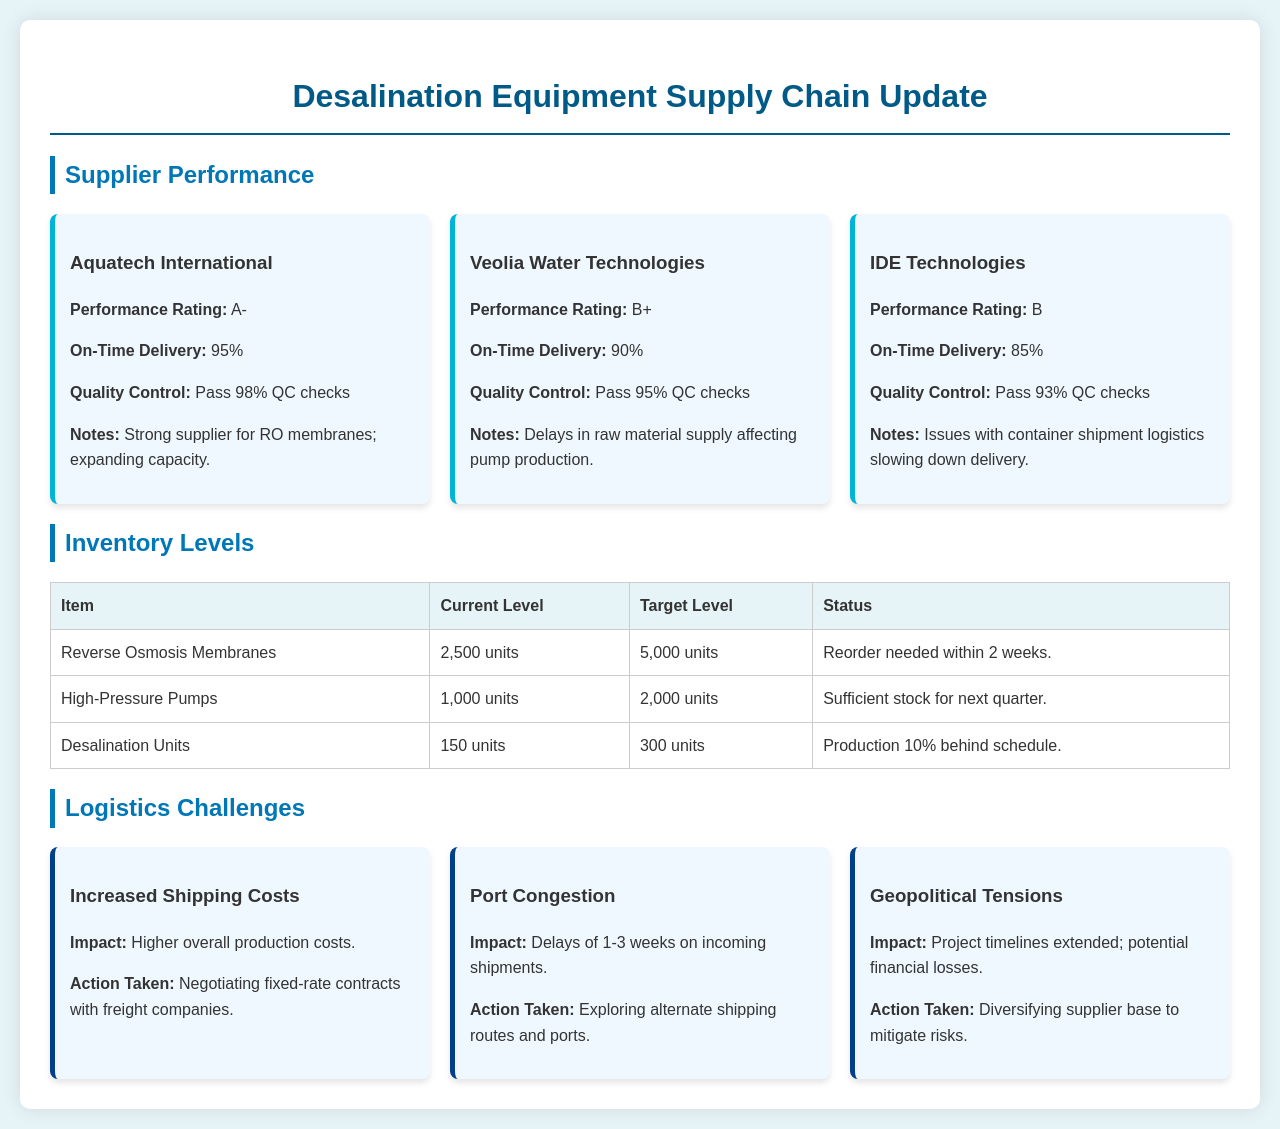What is the performance rating of Aquatech International? Aquatech International's performance rating is specifically stated in the document as A-.
Answer: A- What is the on-time delivery percentage for Veolia Water Technologies? The document lists the on-time delivery percentage for Veolia Water Technologies as 90%.
Answer: 90% How many units of Reverse Osmosis Membranes are currently in stock? The current stock level of Reverse Osmosis Membranes is provided as 2,500 units.
Answer: 2,500 units What logistics challenge is causing delays of 1-3 weeks? The document identifies Port Congestion as a logistics challenge causing delays of 1-3 weeks.
Answer: Port Congestion What action is being taken to mitigate the impact of geopolitical tensions? The document states that diversifying the supplier base is the action being taken to address geopolitical tensions.
Answer: Diversifying supplier base What is the target level for Desalination Units? The target level for Desalination Units is mentioned as 300 units in the document.
Answer: 300 units Which supplier has the highest quality control pass rate? The highest quality control pass rate is 98%, associated with Aquatech International.
Answer: Aquatech International What item is production 10% behind schedule? The item that is production 10% behind schedule is explicitly mentioned as Desalination Units.
Answer: Desalination Units 